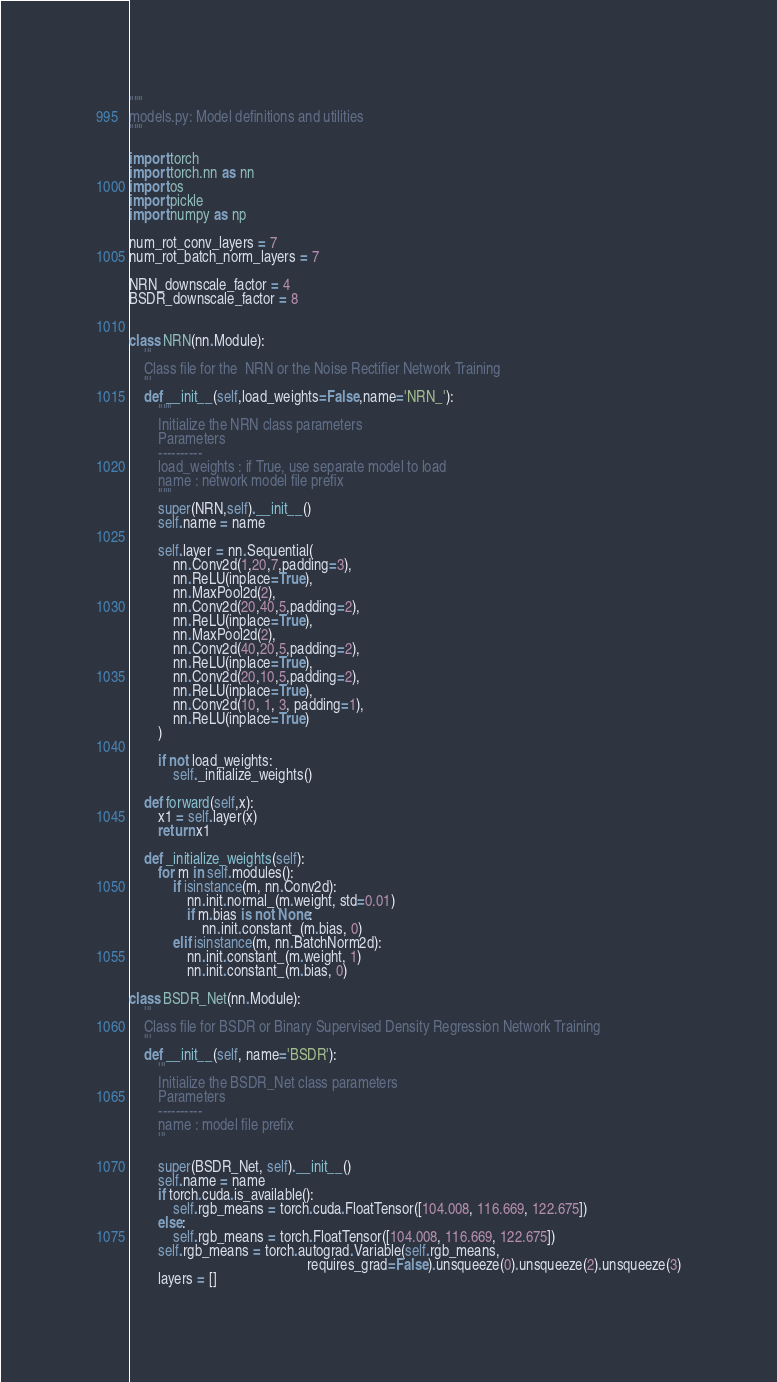Convert code to text. <code><loc_0><loc_0><loc_500><loc_500><_Python_>"""
models.py: Model definitions and utilities
"""

import torch
import torch.nn as nn
import os
import pickle
import numpy as np

num_rot_conv_layers = 7
num_rot_batch_norm_layers = 7

NRN_downscale_factor = 4
BSDR_downscale_factor = 8


class NRN(nn.Module):
    '''
    Class file for the  NRN or the Noise Rectifier Network Training
    '''
    def __init__(self,load_weights=False,name='NRN_'):
        """
        Initialize the NRN class parameters
        Parameters
        ----------
        load_weights : if True, use separate model to load
        name : network model file prefix
        """
        super(NRN,self).__init__()
        self.name = name

        self.layer = nn.Sequential(
            nn.Conv2d(1,20,7,padding=3),
            nn.ReLU(inplace=True),
            nn.MaxPool2d(2),
            nn.Conv2d(20,40,5,padding=2),
            nn.ReLU(inplace=True),
            nn.MaxPool2d(2),
            nn.Conv2d(40,20,5,padding=2),
            nn.ReLU(inplace=True),
            nn.Conv2d(20,10,5,padding=2),
            nn.ReLU(inplace=True),
            nn.Conv2d(10, 1, 3, padding=1),
            nn.ReLU(inplace=True)
        )

        if not load_weights:
            self._initialize_weights()

    def forward(self,x):
        x1 = self.layer(x)
        return x1

    def _initialize_weights(self):
        for m in self.modules():
            if isinstance(m, nn.Conv2d):
                nn.init.normal_(m.weight, std=0.01)
                if m.bias is not None:
                    nn.init.constant_(m.bias, 0)
            elif isinstance(m, nn.BatchNorm2d):
                nn.init.constant_(m.weight, 1)
                nn.init.constant_(m.bias, 0)

class BSDR_Net(nn.Module):
    '''
    Class file for BSDR or Binary Supervised Density Regression Network Training
    '''
    def __init__(self, name='BSDR'):
        '''
        Initialize the BSDR_Net class parameters
        Parameters
        ----------
        name : model file prefix
        '''

        super(BSDR_Net, self).__init__()
        self.name = name
        if torch.cuda.is_available():
            self.rgb_means = torch.cuda.FloatTensor([104.008, 116.669, 122.675])
        else:
            self.rgb_means = torch.FloatTensor([104.008, 116.669, 122.675])
        self.rgb_means = torch.autograd.Variable(self.rgb_means,
                                                 requires_grad=False).unsqueeze(0).unsqueeze(2).unsqueeze(3)
        layers = []</code> 